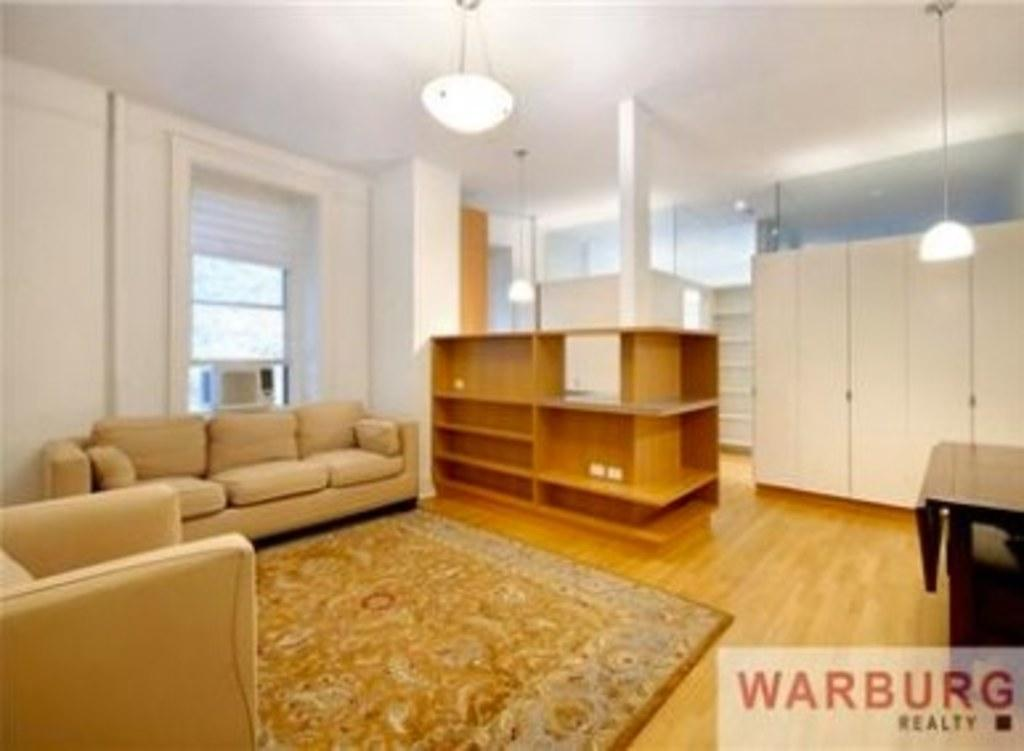What is the color of the wall in the image? The wall in the image is white. What type of furniture can be seen in the image? There are sofas in the image. Is there any source of light in the image? Yes, there is a light in the image. What type of floor covering is present in the image? There is a mat in the image. What type of advertisement can be seen on the wall in the image? There is no advertisement present on the wall in the image; it is a plain white wall. 